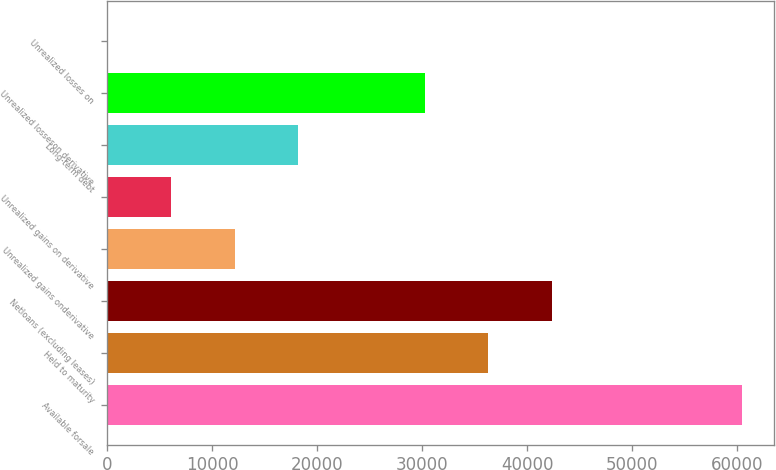Convert chart. <chart><loc_0><loc_0><loc_500><loc_500><bar_chart><fcel>Available forsale<fcel>Held to maturity<fcel>Netloans (excluding leases)<fcel>Unrealized gains onderivative<fcel>Unrealized gains on derivative<fcel>Long-term debt<fcel>Unrealized losseson derivative<fcel>Unrealized losses on<nl><fcel>60445<fcel>36279.4<fcel>42320.8<fcel>12113.8<fcel>6072.4<fcel>18155.2<fcel>30238<fcel>31<nl></chart> 